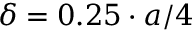<formula> <loc_0><loc_0><loc_500><loc_500>\delta = 0 . 2 5 \cdot a / 4</formula> 